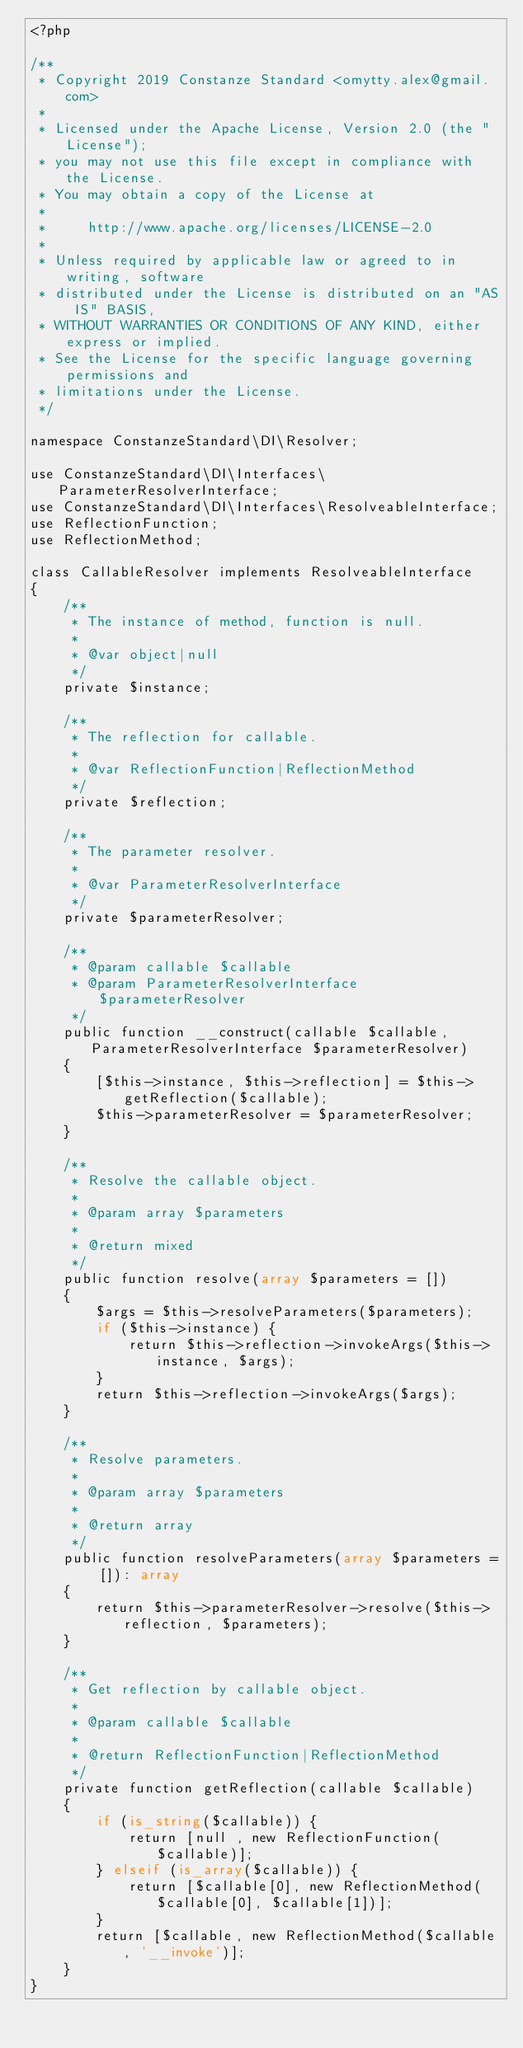Convert code to text. <code><loc_0><loc_0><loc_500><loc_500><_PHP_><?php

/**
 * Copyright 2019 Constanze Standard <omytty.alex@gmail.com>
 * 
 * Licensed under the Apache License, Version 2.0 (the "License");
 * you may not use this file except in compliance with the License.
 * You may obtain a copy of the License at
 * 
 *     http://www.apache.org/licenses/LICENSE-2.0
 * 
 * Unless required by applicable law or agreed to in writing, software
 * distributed under the License is distributed on an "AS IS" BASIS,
 * WITHOUT WARRANTIES OR CONDITIONS OF ANY KIND, either express or implied.
 * See the License for the specific language governing permissions and
 * limitations under the License.
 */

namespace ConstanzeStandard\DI\Resolver;

use ConstanzeStandard\DI\Interfaces\ParameterResolverInterface;
use ConstanzeStandard\DI\Interfaces\ResolveableInterface;
use ReflectionFunction;
use ReflectionMethod;

class CallableResolver implements ResolveableInterface
{
    /**
     * The instance of method, function is null.
     * 
     * @var object|null
     */
    private $instance;

    /**
     * The reflection for callable.
     * 
     * @var ReflectionFunction|ReflectionMethod
     */
    private $reflection;

    /**
     * The parameter resolver.
     * 
     * @var ParameterResolverInterface
     */
    private $parameterResolver;

    /**
     * @param callable $callable
     * @param ParameterResolverInterface $parameterResolver
     */
    public function __construct(callable $callable, ParameterResolverInterface $parameterResolver)
    {
        [$this->instance, $this->reflection] = $this->getReflection($callable);
        $this->parameterResolver = $parameterResolver;
    }

    /**
     * Resolve the callable object.
     * 
     * @param array $parameters
     * 
     * @return mixed
     */
    public function resolve(array $parameters = [])
    {
        $args = $this->resolveParameters($parameters);
        if ($this->instance) {
            return $this->reflection->invokeArgs($this->instance, $args);
        }
        return $this->reflection->invokeArgs($args);
    }

    /**
     * Resolve parameters.
     * 
     * @param array $parameters
     * 
     * @return array
     */
    public function resolveParameters(array $parameters = []): array
    {
        return $this->parameterResolver->resolve($this->reflection, $parameters);
    }

    /**
     * Get reflection by callable object.
     * 
     * @param callable $callable
     * 
     * @return ReflectionFunction|ReflectionMethod
     */
    private function getReflection(callable $callable)
    {
        if (is_string($callable)) {
            return [null , new ReflectionFunction($callable)];
        } elseif (is_array($callable)) {
            return [$callable[0], new ReflectionMethod($callable[0], $callable[1])];
        }
        return [$callable, new ReflectionMethod($callable, '__invoke')];
    }
}
</code> 